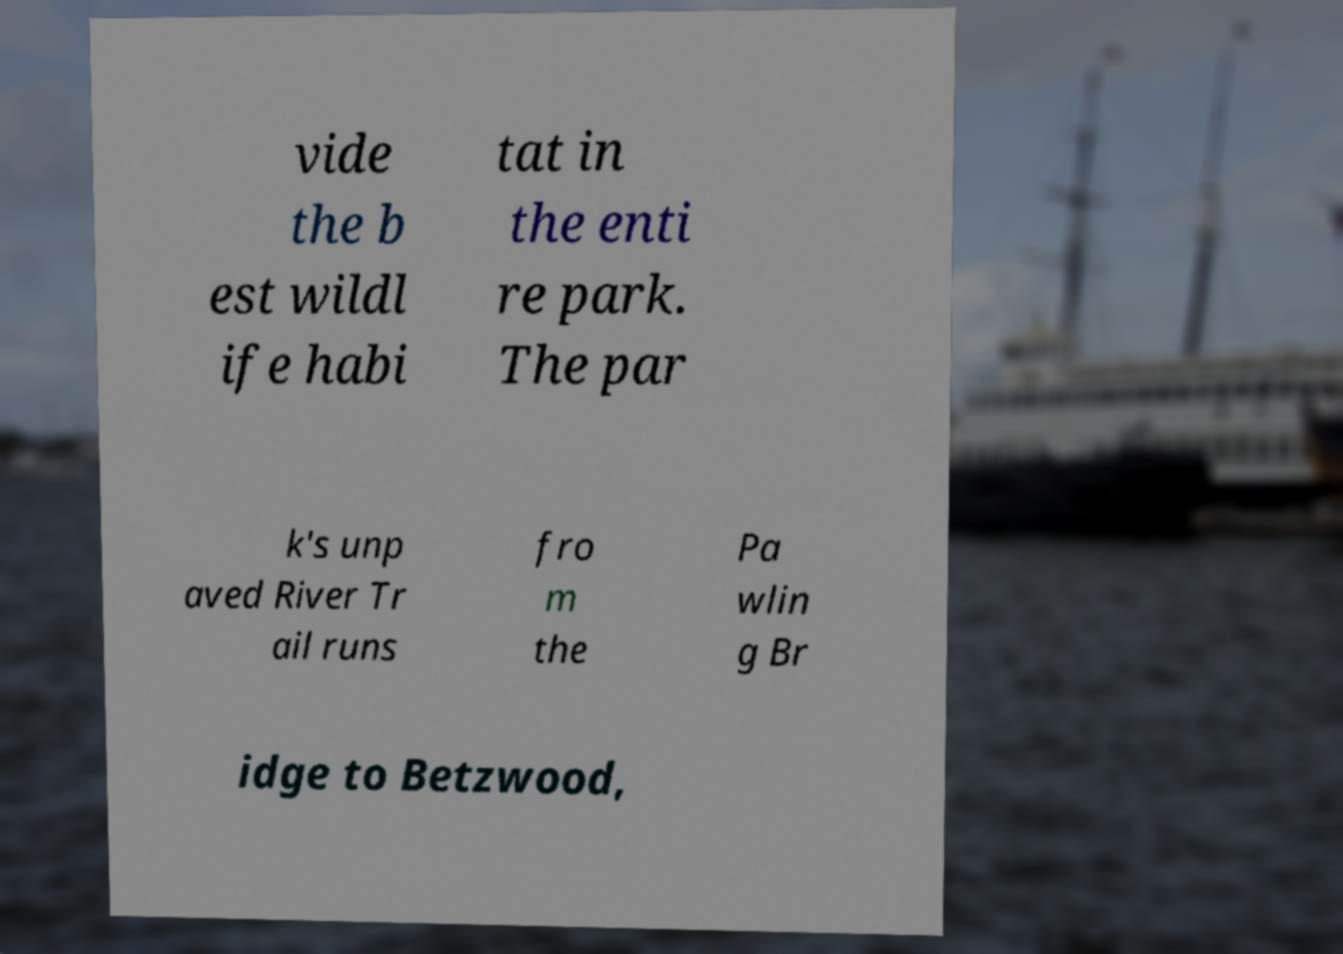There's text embedded in this image that I need extracted. Can you transcribe it verbatim? vide the b est wildl ife habi tat in the enti re park. The par k's unp aved River Tr ail runs fro m the Pa wlin g Br idge to Betzwood, 